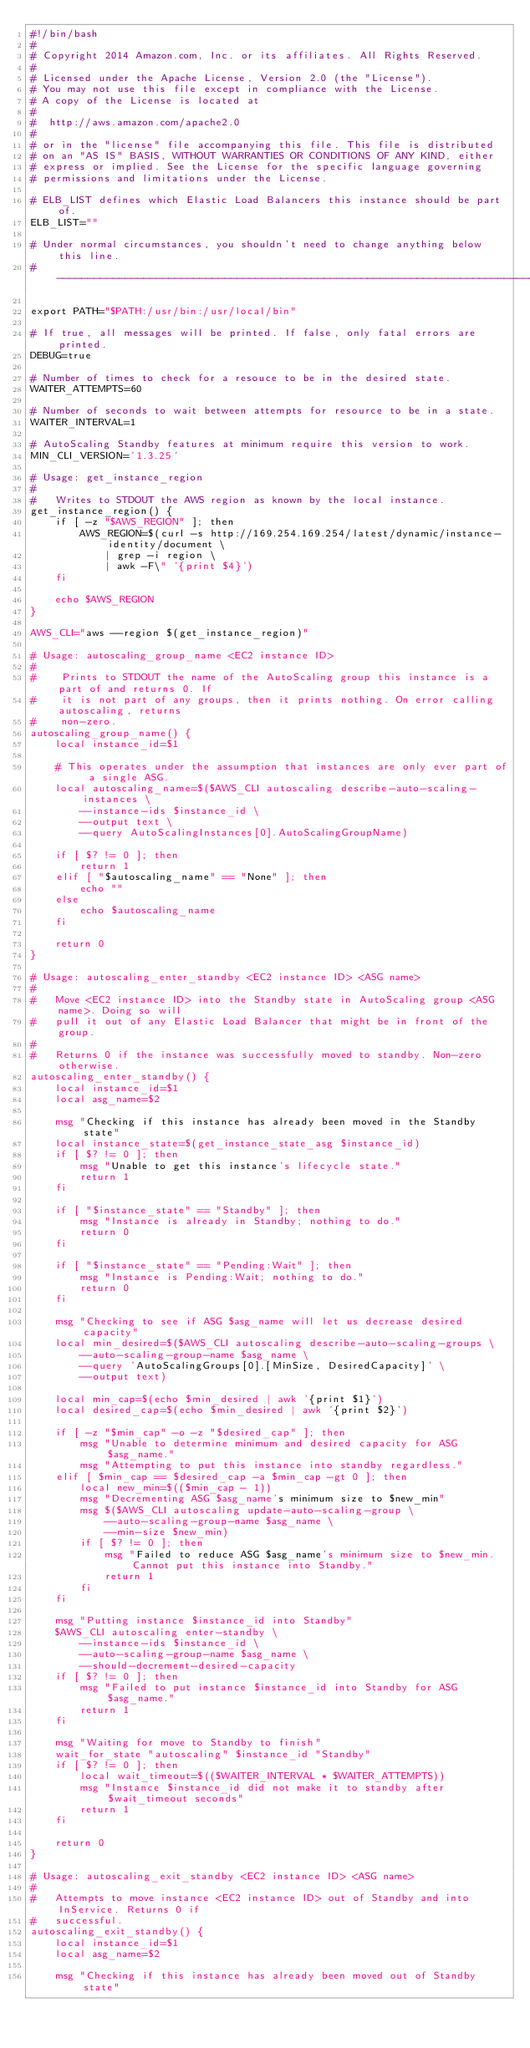Convert code to text. <code><loc_0><loc_0><loc_500><loc_500><_Bash_>#!/bin/bash
#
# Copyright 2014 Amazon.com, Inc. or its affiliates. All Rights Reserved.
#
# Licensed under the Apache License, Version 2.0 (the "License").
# You may not use this file except in compliance with the License.
# A copy of the License is located at
#
#  http://aws.amazon.com/apache2.0
#
# or in the "license" file accompanying this file. This file is distributed
# on an "AS IS" BASIS, WITHOUT WARRANTIES OR CONDITIONS OF ANY KIND, either
# express or implied. See the License for the specific language governing
# permissions and limitations under the License.

# ELB_LIST defines which Elastic Load Balancers this instance should be part of.
ELB_LIST=""

# Under normal circumstances, you shouldn't need to change anything below this line.
# -----------------------------------------------------------------------------

export PATH="$PATH:/usr/bin:/usr/local/bin"

# If true, all messages will be printed. If false, only fatal errors are printed.
DEBUG=true

# Number of times to check for a resouce to be in the desired state.
WAITER_ATTEMPTS=60

# Number of seconds to wait between attempts for resource to be in a state.
WAITER_INTERVAL=1

# AutoScaling Standby features at minimum require this version to work.
MIN_CLI_VERSION='1.3.25'

# Usage: get_instance_region
#
#   Writes to STDOUT the AWS region as known by the local instance.
get_instance_region() {
    if [ -z "$AWS_REGION" ]; then
        AWS_REGION=$(curl -s http://169.254.169.254/latest/dynamic/instance-identity/document \
            | grep -i region \
            | awk -F\" '{print $4}')
    fi

    echo $AWS_REGION
}

AWS_CLI="aws --region $(get_instance_region)"

# Usage: autoscaling_group_name <EC2 instance ID>
#
#    Prints to STDOUT the name of the AutoScaling group this instance is a part of and returns 0. If
#    it is not part of any groups, then it prints nothing. On error calling autoscaling, returns
#    non-zero.
autoscaling_group_name() {
    local instance_id=$1

    # This operates under the assumption that instances are only ever part of a single ASG.
    local autoscaling_name=$($AWS_CLI autoscaling describe-auto-scaling-instances \
        --instance-ids $instance_id \
        --output text \
        --query AutoScalingInstances[0].AutoScalingGroupName)

    if [ $? != 0 ]; then
        return 1
    elif [ "$autoscaling_name" == "None" ]; then
        echo ""
    else
        echo $autoscaling_name
    fi

    return 0
}

# Usage: autoscaling_enter_standby <EC2 instance ID> <ASG name>
#
#   Move <EC2 instance ID> into the Standby state in AutoScaling group <ASG name>. Doing so will
#   pull it out of any Elastic Load Balancer that might be in front of the group.
#
#   Returns 0 if the instance was successfully moved to standby. Non-zero otherwise.
autoscaling_enter_standby() {
    local instance_id=$1
    local asg_name=$2

    msg "Checking if this instance has already been moved in the Standby state"
    local instance_state=$(get_instance_state_asg $instance_id)
    if [ $? != 0 ]; then
        msg "Unable to get this instance's lifecycle state."
        return 1
    fi

    if [ "$instance_state" == "Standby" ]; then
        msg "Instance is already in Standby; nothing to do."
        return 0
    fi

    if [ "$instance_state" == "Pending:Wait" ]; then
        msg "Instance is Pending:Wait; nothing to do."
        return 0
    fi

    msg "Checking to see if ASG $asg_name will let us decrease desired capacity"
    local min_desired=$($AWS_CLI autoscaling describe-auto-scaling-groups \
        --auto-scaling-group-name $asg_name \
        --query 'AutoScalingGroups[0].[MinSize, DesiredCapacity]' \
        --output text)

    local min_cap=$(echo $min_desired | awk '{print $1}')
    local desired_cap=$(echo $min_desired | awk '{print $2}')

    if [ -z "$min_cap" -o -z "$desired_cap" ]; then
        msg "Unable to determine minimum and desired capacity for ASG $asg_name."
        msg "Attempting to put this instance into standby regardless."
    elif [ $min_cap == $desired_cap -a $min_cap -gt 0 ]; then
        local new_min=$(($min_cap - 1))
        msg "Decrementing ASG $asg_name's minimum size to $new_min"
        msg $($AWS_CLI autoscaling update-auto-scaling-group \
            --auto-scaling-group-name $asg_name \
            --min-size $new_min)
        if [ $? != 0 ]; then
            msg "Failed to reduce ASG $asg_name's minimum size to $new_min. Cannot put this instance into Standby."
            return 1
        fi
    fi

    msg "Putting instance $instance_id into Standby"
    $AWS_CLI autoscaling enter-standby \
        --instance-ids $instance_id \
        --auto-scaling-group-name $asg_name \
        --should-decrement-desired-capacity
    if [ $? != 0 ]; then
        msg "Failed to put instance $instance_id into Standby for ASG $asg_name."
        return 1
    fi

    msg "Waiting for move to Standby to finish"
    wait_for_state "autoscaling" $instance_id "Standby"
    if [ $? != 0 ]; then
        local wait_timeout=$(($WAITER_INTERVAL * $WAITER_ATTEMPTS))
        msg "Instance $instance_id did not make it to standby after $wait_timeout seconds"
        return 1
    fi

    return 0
}

# Usage: autoscaling_exit_standby <EC2 instance ID> <ASG name>
#
#   Attempts to move instance <EC2 instance ID> out of Standby and into InService. Returns 0 if
#   successful.
autoscaling_exit_standby() {
    local instance_id=$1
    local asg_name=$2

    msg "Checking if this instance has already been moved out of Standby state"</code> 